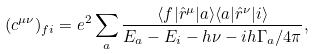<formula> <loc_0><loc_0><loc_500><loc_500>( c ^ { \mu \nu } ) _ { f i } = e ^ { 2 } \sum _ { a } \frac { \langle f | \hat { r } ^ { \mu } | a \rangle \langle a | \hat { r } ^ { \nu } | i \rangle } { E _ { a } - E _ { i } - h \nu - i h \Gamma _ { a } / 4 \pi } ,</formula> 